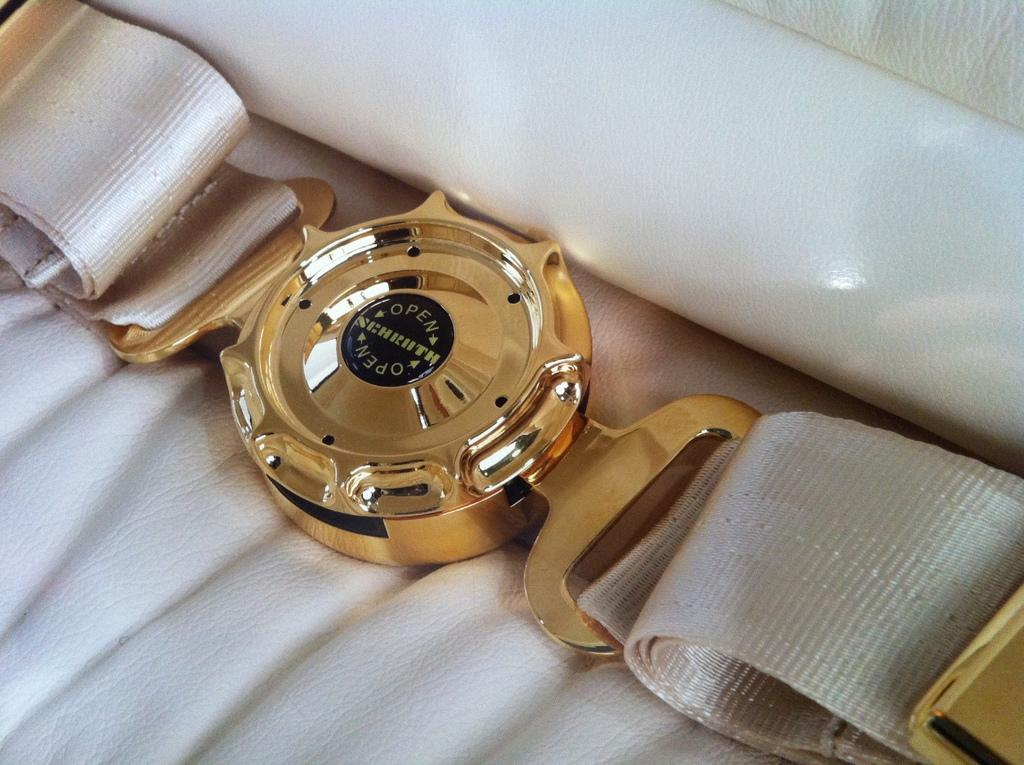<image>
Summarize the visual content of the image. A gold seatbelt buckle with the words "Open" on either side of a small black inlaid circle. 